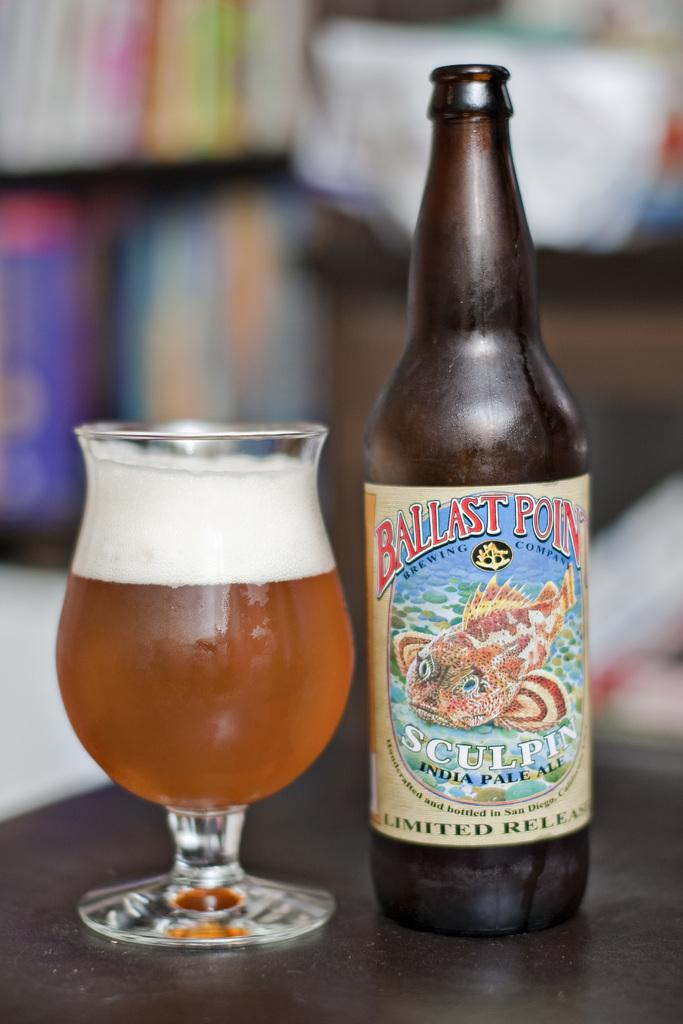<image>
Render a clear and concise summary of the photo. A glass of beer is adjacent to a bottle of Ballast Point Sculpin India Pale Ale. 